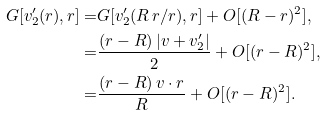Convert formula to latex. <formula><loc_0><loc_0><loc_500><loc_500>G [ v ^ { \prime } _ { 2 } ( r ) , r ] = & G [ v ^ { \prime } _ { 2 } ( R \, r / r ) , r ] + O [ ( R - r ) ^ { 2 } ] , \\ = & \frac { ( r - R ) \, | v + v ^ { \prime } _ { 2 } | } { 2 } + O [ ( r - R ) ^ { 2 } ] , \\ = & \frac { ( r - R ) \, v \cdot r } { R } + O [ ( r - R ) ^ { 2 } ] .</formula> 